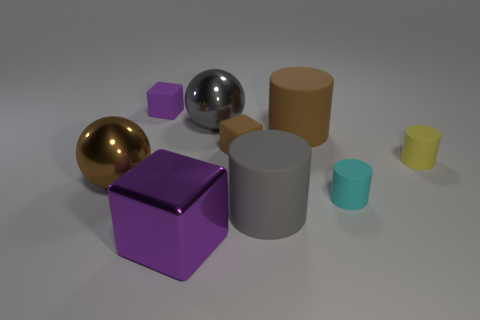What is the shape of the small thing that is the same color as the shiny block?
Offer a terse response. Cube. What number of other purple metallic cubes are the same size as the purple metal block?
Your answer should be very brief. 0. What shape is the large metallic object behind the small yellow cylinder?
Offer a terse response. Sphere. Are there fewer tiny cyan matte objects than metallic objects?
Offer a terse response. Yes. Is there anything else that has the same color as the big metallic block?
Your answer should be very brief. Yes. There is a rubber object that is left of the tiny brown block; how big is it?
Your answer should be very brief. Small. Are there more cyan matte cylinders than metal things?
Offer a terse response. No. What is the gray ball made of?
Give a very brief answer. Metal. How many other things are made of the same material as the gray cylinder?
Your response must be concise. 5. What number of green cylinders are there?
Your answer should be very brief. 0. 